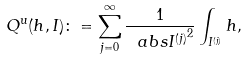<formula> <loc_0><loc_0><loc_500><loc_500>Q ^ { u } ( h , I ) \colon = \sum _ { j = 0 } ^ { \infty } \frac { 1 } { \ a b s { I ^ { ( j ) } } ^ { 2 } } \int _ { I ^ { ( j ) } } h ,</formula> 